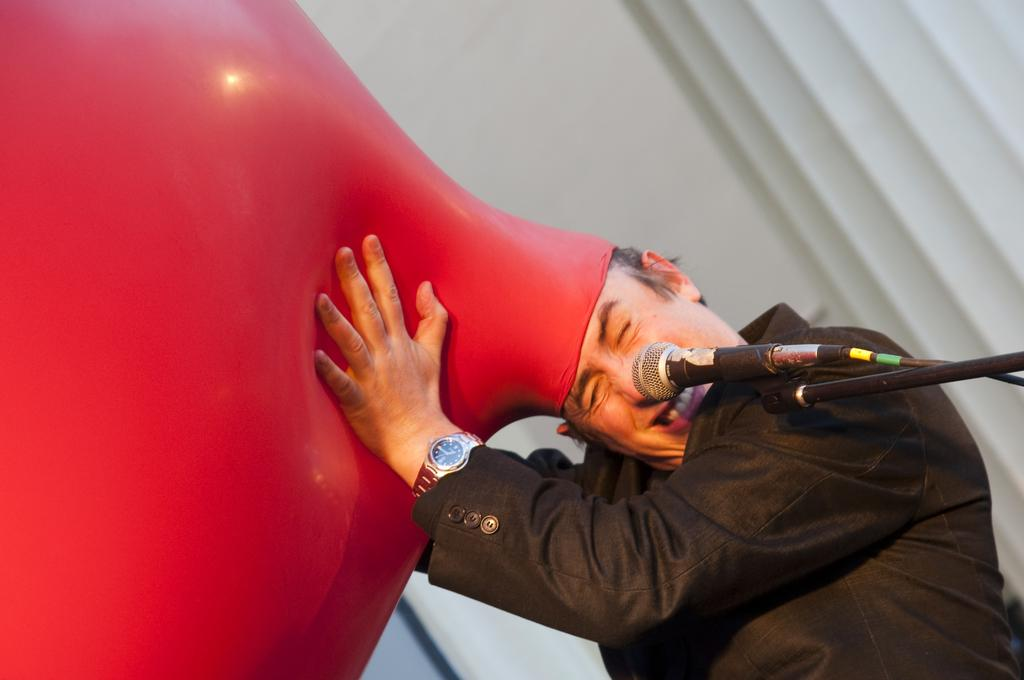Where is the man located in the image? The man is standing in the bottom right side of the image. What is the man holding in the image? The man is holding a balloon. What is behind the man in the image? There is a wall behind the man. What object related to sound can be seen in the image? There is a microphone in the image. What type of bells can be heard ringing in the image? There are no bells present in the image, and therefore no sound can be heard. Is there a crook visible in the image? There is no crook present in the image. 